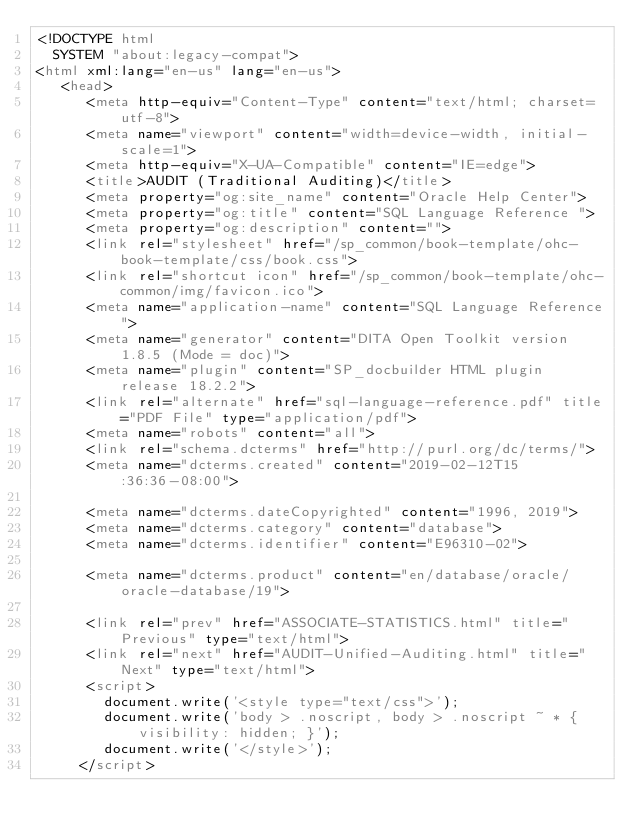<code> <loc_0><loc_0><loc_500><loc_500><_HTML_><!DOCTYPE html
  SYSTEM "about:legacy-compat">
<html xml:lang="en-us" lang="en-us">
   <head>
      <meta http-equiv="Content-Type" content="text/html; charset=utf-8">
      <meta name="viewport" content="width=device-width, initial-scale=1">
      <meta http-equiv="X-UA-Compatible" content="IE=edge">
      <title>AUDIT (Traditional Auditing)</title>
      <meta property="og:site_name" content="Oracle Help Center">
      <meta property="og:title" content="SQL Language Reference ">
      <meta property="og:description" content="">
      <link rel="stylesheet" href="/sp_common/book-template/ohc-book-template/css/book.css">
      <link rel="shortcut icon" href="/sp_common/book-template/ohc-common/img/favicon.ico">
      <meta name="application-name" content="SQL Language Reference">
      <meta name="generator" content="DITA Open Toolkit version 1.8.5 (Mode = doc)">
      <meta name="plugin" content="SP_docbuilder HTML plugin release 18.2.2">
      <link rel="alternate" href="sql-language-reference.pdf" title="PDF File" type="application/pdf">
      <meta name="robots" content="all">
      <link rel="schema.dcterms" href="http://purl.org/dc/terms/">
      <meta name="dcterms.created" content="2019-02-12T15:36:36-08:00">
      
      <meta name="dcterms.dateCopyrighted" content="1996, 2019">
      <meta name="dcterms.category" content="database">
      <meta name="dcterms.identifier" content="E96310-02">
      
      <meta name="dcterms.product" content="en/database/oracle/oracle-database/19">
      
      <link rel="prev" href="ASSOCIATE-STATISTICS.html" title="Previous" type="text/html">
      <link rel="next" href="AUDIT-Unified-Auditing.html" title="Next" type="text/html">
      <script>
        document.write('<style type="text/css">');
        document.write('body > .noscript, body > .noscript ~ * { visibility: hidden; }');
        document.write('</style>');
     </script></code> 